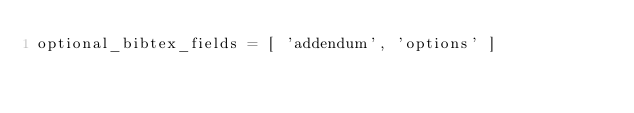<code> <loc_0><loc_0><loc_500><loc_500><_Python_>optional_bibtex_fields = [ 'addendum', 'options' ]
</code> 